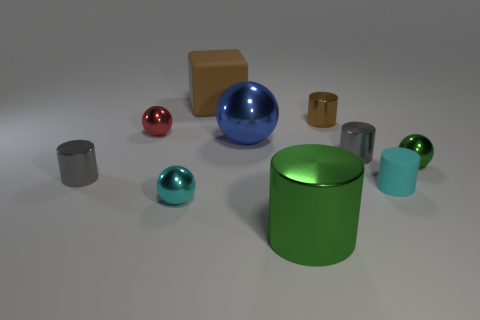Subtract all green spheres. How many gray cylinders are left? 2 Subtract all small cylinders. How many cylinders are left? 1 Subtract all blue spheres. How many spheres are left? 3 Subtract 3 cylinders. How many cylinders are left? 2 Subtract all blocks. How many objects are left? 9 Subtract all brown cylinders. Subtract all purple blocks. How many cylinders are left? 4 Add 1 small shiny cylinders. How many small shiny cylinders exist? 4 Subtract 0 brown spheres. How many objects are left? 10 Subtract all brown objects. Subtract all big brown rubber cubes. How many objects are left? 7 Add 6 cyan metallic spheres. How many cyan metallic spheres are left? 7 